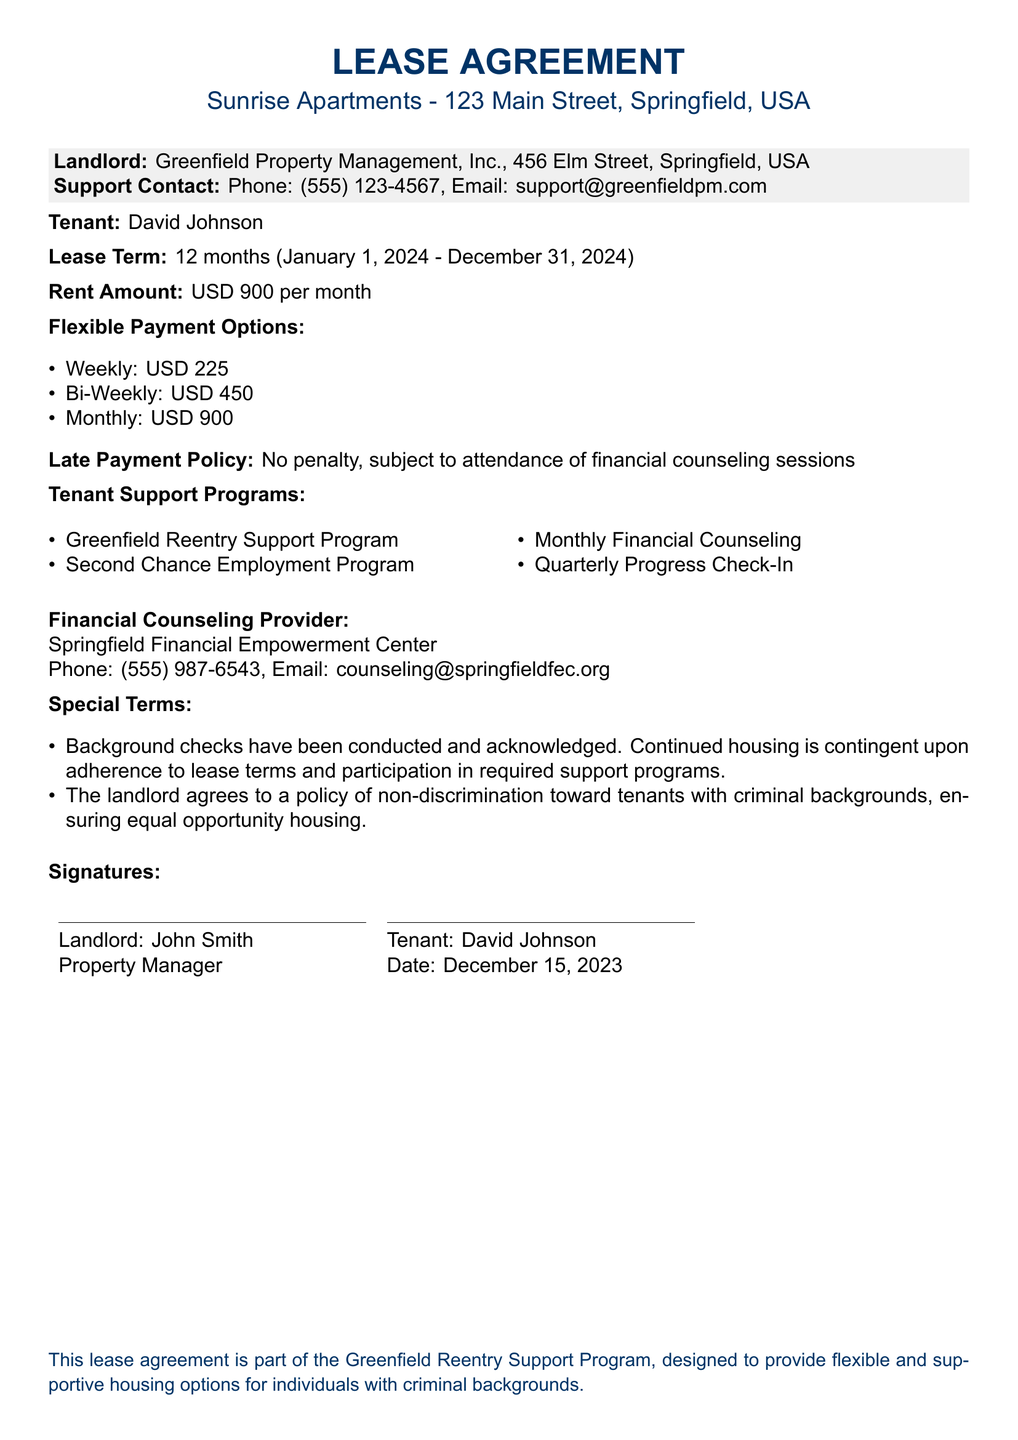What is the tenant's name? The tenant's name is given in the lease agreement, which is David Johnson.
Answer: David Johnson What is the monthly rent amount? The lease agreement specifies the rent amount as USD 900 per month.
Answer: USD 900 What are the flexible payment options available? The lease outlines three types of flexible payment options: weekly, bi-weekly, and monthly.
Answer: Weekly, Bi-Weekly, Monthly How does the late payment policy work? The policy states there is no penalty for late payments as long as the tenant attends financial counseling sessions.
Answer: No penalty, subject to attendance of financial counseling sessions What is the contact information for the financial counseling provider? The document lists the phone number and email for the Springfield Financial Empowerment Center, which provides counseling.
Answer: Phone: (555) 987-6543, Email: counseling@springfieldfec.org What is the lease term duration? The lease agreement clearly states the start and end dates of the lease term, which is 12 months.
Answer: 12 months What programs are part of tenant support? The lease specifies multiple support programs available for tenants, which includes various initiatives to assist them.
Answer: Greenfield Reentry Support Program, Second Chance Employment Program, Monthly Financial Counseling, Quarterly Progress Check-In What ensures equal opportunity housing in the agreement? The document includes a statement about the landlord's non-discrimination policy towards tenants with criminal backgrounds.
Answer: Non-discrimination policy 